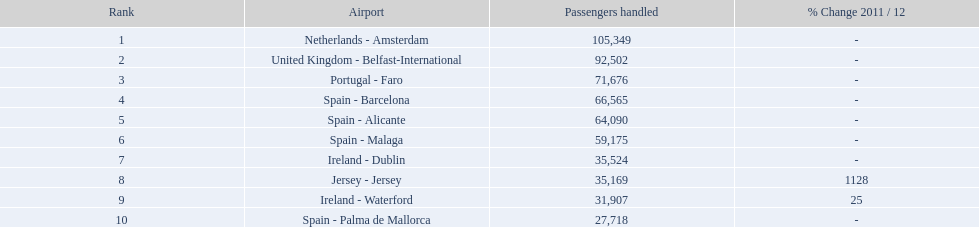In 2012, how many spanish airports were part of the top 10 busiest routes to and from london southend airport? 4. I'm looking to parse the entire table for insights. Could you assist me with that? {'header': ['Rank', 'Airport', 'Passengers handled', '% Change 2011 / 12'], 'rows': [['1', 'Netherlands - Amsterdam', '105,349', '-'], ['2', 'United Kingdom - Belfast-International', '92,502', '-'], ['3', 'Portugal - Faro', '71,676', '-'], ['4', 'Spain - Barcelona', '66,565', '-'], ['5', 'Spain - Alicante', '64,090', '-'], ['6', 'Spain - Malaga', '59,175', '-'], ['7', 'Ireland - Dublin', '35,524', '-'], ['8', 'Jersey - Jersey', '35,169', '1128'], ['9', 'Ireland - Waterford', '31,907', '25'], ['10', 'Spain - Palma de Mallorca', '27,718', '-']]} 